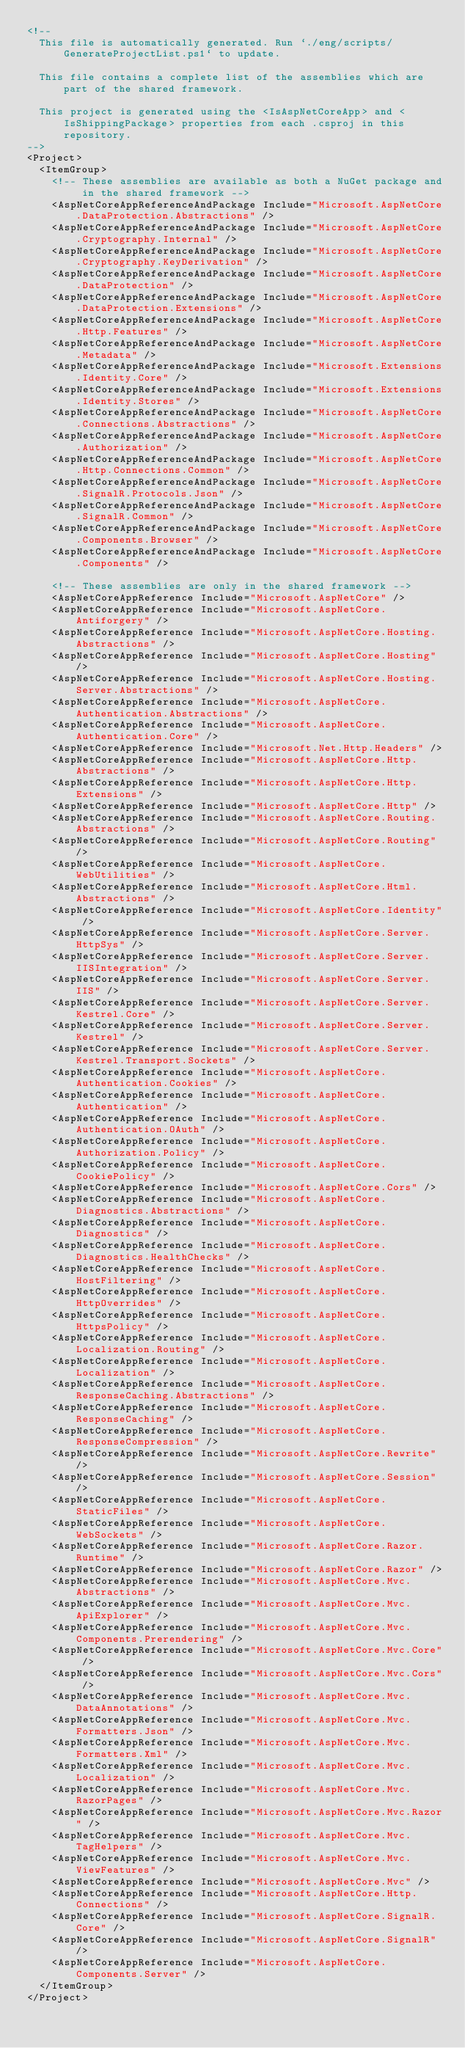Convert code to text. <code><loc_0><loc_0><loc_500><loc_500><_XML_><!--
  This file is automatically generated. Run `./eng/scripts/GenerateProjectList.ps1` to update.

  This file contains a complete list of the assemblies which are part of the shared framework.

  This project is generated using the <IsAspNetCoreApp> and <IsShippingPackage> properties from each .csproj in this repository.
-->
<Project>
  <ItemGroup>
    <!-- These assemblies are available as both a NuGet package and in the shared framework -->
    <AspNetCoreAppReferenceAndPackage Include="Microsoft.AspNetCore.DataProtection.Abstractions" />
    <AspNetCoreAppReferenceAndPackage Include="Microsoft.AspNetCore.Cryptography.Internal" />
    <AspNetCoreAppReferenceAndPackage Include="Microsoft.AspNetCore.Cryptography.KeyDerivation" />
    <AspNetCoreAppReferenceAndPackage Include="Microsoft.AspNetCore.DataProtection" />
    <AspNetCoreAppReferenceAndPackage Include="Microsoft.AspNetCore.DataProtection.Extensions" />
    <AspNetCoreAppReferenceAndPackage Include="Microsoft.AspNetCore.Http.Features" />
    <AspNetCoreAppReferenceAndPackage Include="Microsoft.AspNetCore.Metadata" />
    <AspNetCoreAppReferenceAndPackage Include="Microsoft.Extensions.Identity.Core" />
    <AspNetCoreAppReferenceAndPackage Include="Microsoft.Extensions.Identity.Stores" />
    <AspNetCoreAppReferenceAndPackage Include="Microsoft.AspNetCore.Connections.Abstractions" />
    <AspNetCoreAppReferenceAndPackage Include="Microsoft.AspNetCore.Authorization" />
    <AspNetCoreAppReferenceAndPackage Include="Microsoft.AspNetCore.Http.Connections.Common" />
    <AspNetCoreAppReferenceAndPackage Include="Microsoft.AspNetCore.SignalR.Protocols.Json" />
    <AspNetCoreAppReferenceAndPackage Include="Microsoft.AspNetCore.SignalR.Common" />
    <AspNetCoreAppReferenceAndPackage Include="Microsoft.AspNetCore.Components.Browser" />
    <AspNetCoreAppReferenceAndPackage Include="Microsoft.AspNetCore.Components" />

    <!-- These assemblies are only in the shared framework -->
    <AspNetCoreAppReference Include="Microsoft.AspNetCore" />
    <AspNetCoreAppReference Include="Microsoft.AspNetCore.Antiforgery" />
    <AspNetCoreAppReference Include="Microsoft.AspNetCore.Hosting.Abstractions" />
    <AspNetCoreAppReference Include="Microsoft.AspNetCore.Hosting" />
    <AspNetCoreAppReference Include="Microsoft.AspNetCore.Hosting.Server.Abstractions" />
    <AspNetCoreAppReference Include="Microsoft.AspNetCore.Authentication.Abstractions" />
    <AspNetCoreAppReference Include="Microsoft.AspNetCore.Authentication.Core" />
    <AspNetCoreAppReference Include="Microsoft.Net.Http.Headers" />
    <AspNetCoreAppReference Include="Microsoft.AspNetCore.Http.Abstractions" />
    <AspNetCoreAppReference Include="Microsoft.AspNetCore.Http.Extensions" />
    <AspNetCoreAppReference Include="Microsoft.AspNetCore.Http" />
    <AspNetCoreAppReference Include="Microsoft.AspNetCore.Routing.Abstractions" />
    <AspNetCoreAppReference Include="Microsoft.AspNetCore.Routing" />
    <AspNetCoreAppReference Include="Microsoft.AspNetCore.WebUtilities" />
    <AspNetCoreAppReference Include="Microsoft.AspNetCore.Html.Abstractions" />
    <AspNetCoreAppReference Include="Microsoft.AspNetCore.Identity" />
    <AspNetCoreAppReference Include="Microsoft.AspNetCore.Server.HttpSys" />
    <AspNetCoreAppReference Include="Microsoft.AspNetCore.Server.IISIntegration" />
    <AspNetCoreAppReference Include="Microsoft.AspNetCore.Server.IIS" />
    <AspNetCoreAppReference Include="Microsoft.AspNetCore.Server.Kestrel.Core" />
    <AspNetCoreAppReference Include="Microsoft.AspNetCore.Server.Kestrel" />
    <AspNetCoreAppReference Include="Microsoft.AspNetCore.Server.Kestrel.Transport.Sockets" />
    <AspNetCoreAppReference Include="Microsoft.AspNetCore.Authentication.Cookies" />
    <AspNetCoreAppReference Include="Microsoft.AspNetCore.Authentication" />
    <AspNetCoreAppReference Include="Microsoft.AspNetCore.Authentication.OAuth" />
    <AspNetCoreAppReference Include="Microsoft.AspNetCore.Authorization.Policy" />
    <AspNetCoreAppReference Include="Microsoft.AspNetCore.CookiePolicy" />
    <AspNetCoreAppReference Include="Microsoft.AspNetCore.Cors" />
    <AspNetCoreAppReference Include="Microsoft.AspNetCore.Diagnostics.Abstractions" />
    <AspNetCoreAppReference Include="Microsoft.AspNetCore.Diagnostics" />
    <AspNetCoreAppReference Include="Microsoft.AspNetCore.Diagnostics.HealthChecks" />
    <AspNetCoreAppReference Include="Microsoft.AspNetCore.HostFiltering" />
    <AspNetCoreAppReference Include="Microsoft.AspNetCore.HttpOverrides" />
    <AspNetCoreAppReference Include="Microsoft.AspNetCore.HttpsPolicy" />
    <AspNetCoreAppReference Include="Microsoft.AspNetCore.Localization.Routing" />
    <AspNetCoreAppReference Include="Microsoft.AspNetCore.Localization" />
    <AspNetCoreAppReference Include="Microsoft.AspNetCore.ResponseCaching.Abstractions" />
    <AspNetCoreAppReference Include="Microsoft.AspNetCore.ResponseCaching" />
    <AspNetCoreAppReference Include="Microsoft.AspNetCore.ResponseCompression" />
    <AspNetCoreAppReference Include="Microsoft.AspNetCore.Rewrite" />
    <AspNetCoreAppReference Include="Microsoft.AspNetCore.Session" />
    <AspNetCoreAppReference Include="Microsoft.AspNetCore.StaticFiles" />
    <AspNetCoreAppReference Include="Microsoft.AspNetCore.WebSockets" />
    <AspNetCoreAppReference Include="Microsoft.AspNetCore.Razor.Runtime" />
    <AspNetCoreAppReference Include="Microsoft.AspNetCore.Razor" />
    <AspNetCoreAppReference Include="Microsoft.AspNetCore.Mvc.Abstractions" />
    <AspNetCoreAppReference Include="Microsoft.AspNetCore.Mvc.ApiExplorer" />
    <AspNetCoreAppReference Include="Microsoft.AspNetCore.Mvc.Components.Prerendering" />
    <AspNetCoreAppReference Include="Microsoft.AspNetCore.Mvc.Core" />
    <AspNetCoreAppReference Include="Microsoft.AspNetCore.Mvc.Cors" />
    <AspNetCoreAppReference Include="Microsoft.AspNetCore.Mvc.DataAnnotations" />
    <AspNetCoreAppReference Include="Microsoft.AspNetCore.Mvc.Formatters.Json" />
    <AspNetCoreAppReference Include="Microsoft.AspNetCore.Mvc.Formatters.Xml" />
    <AspNetCoreAppReference Include="Microsoft.AspNetCore.Mvc.Localization" />
    <AspNetCoreAppReference Include="Microsoft.AspNetCore.Mvc.RazorPages" />
    <AspNetCoreAppReference Include="Microsoft.AspNetCore.Mvc.Razor" />
    <AspNetCoreAppReference Include="Microsoft.AspNetCore.Mvc.TagHelpers" />
    <AspNetCoreAppReference Include="Microsoft.AspNetCore.Mvc.ViewFeatures" />
    <AspNetCoreAppReference Include="Microsoft.AspNetCore.Mvc" />
    <AspNetCoreAppReference Include="Microsoft.AspNetCore.Http.Connections" />
    <AspNetCoreAppReference Include="Microsoft.AspNetCore.SignalR.Core" />
    <AspNetCoreAppReference Include="Microsoft.AspNetCore.SignalR" />
    <AspNetCoreAppReference Include="Microsoft.AspNetCore.Components.Server" />
  </ItemGroup>
</Project>
</code> 